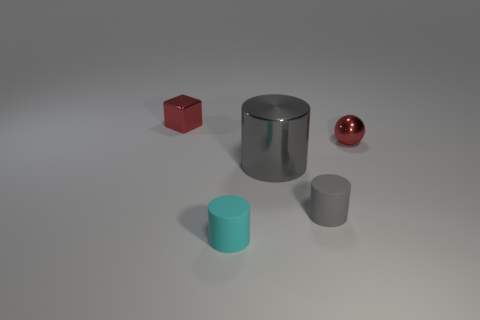Is there anything else that has the same size as the shiny cylinder?
Make the answer very short. No. Is the number of small red balls behind the tiny cyan cylinder the same as the number of cyan things that are in front of the block?
Keep it short and to the point. Yes. What material is the large gray object that is the same shape as the tiny cyan matte object?
Make the answer very short. Metal. There is a tiny shiny thing that is on the right side of the thing that is behind the ball; are there any tiny balls that are in front of it?
Keep it short and to the point. No. There is a tiny gray object in front of the big gray metal thing; does it have the same shape as the tiny red metallic thing to the right of the small red cube?
Offer a very short reply. No. Are there more small balls on the left side of the small red metal ball than red spheres?
Ensure brevity in your answer.  No. What number of objects are tiny yellow shiny balls or small matte things?
Your answer should be very brief. 2. What is the color of the metallic block?
Make the answer very short. Red. How many other objects are the same color as the shiny sphere?
Ensure brevity in your answer.  1. Are there any blocks on the right side of the small cyan cylinder?
Keep it short and to the point. No. 